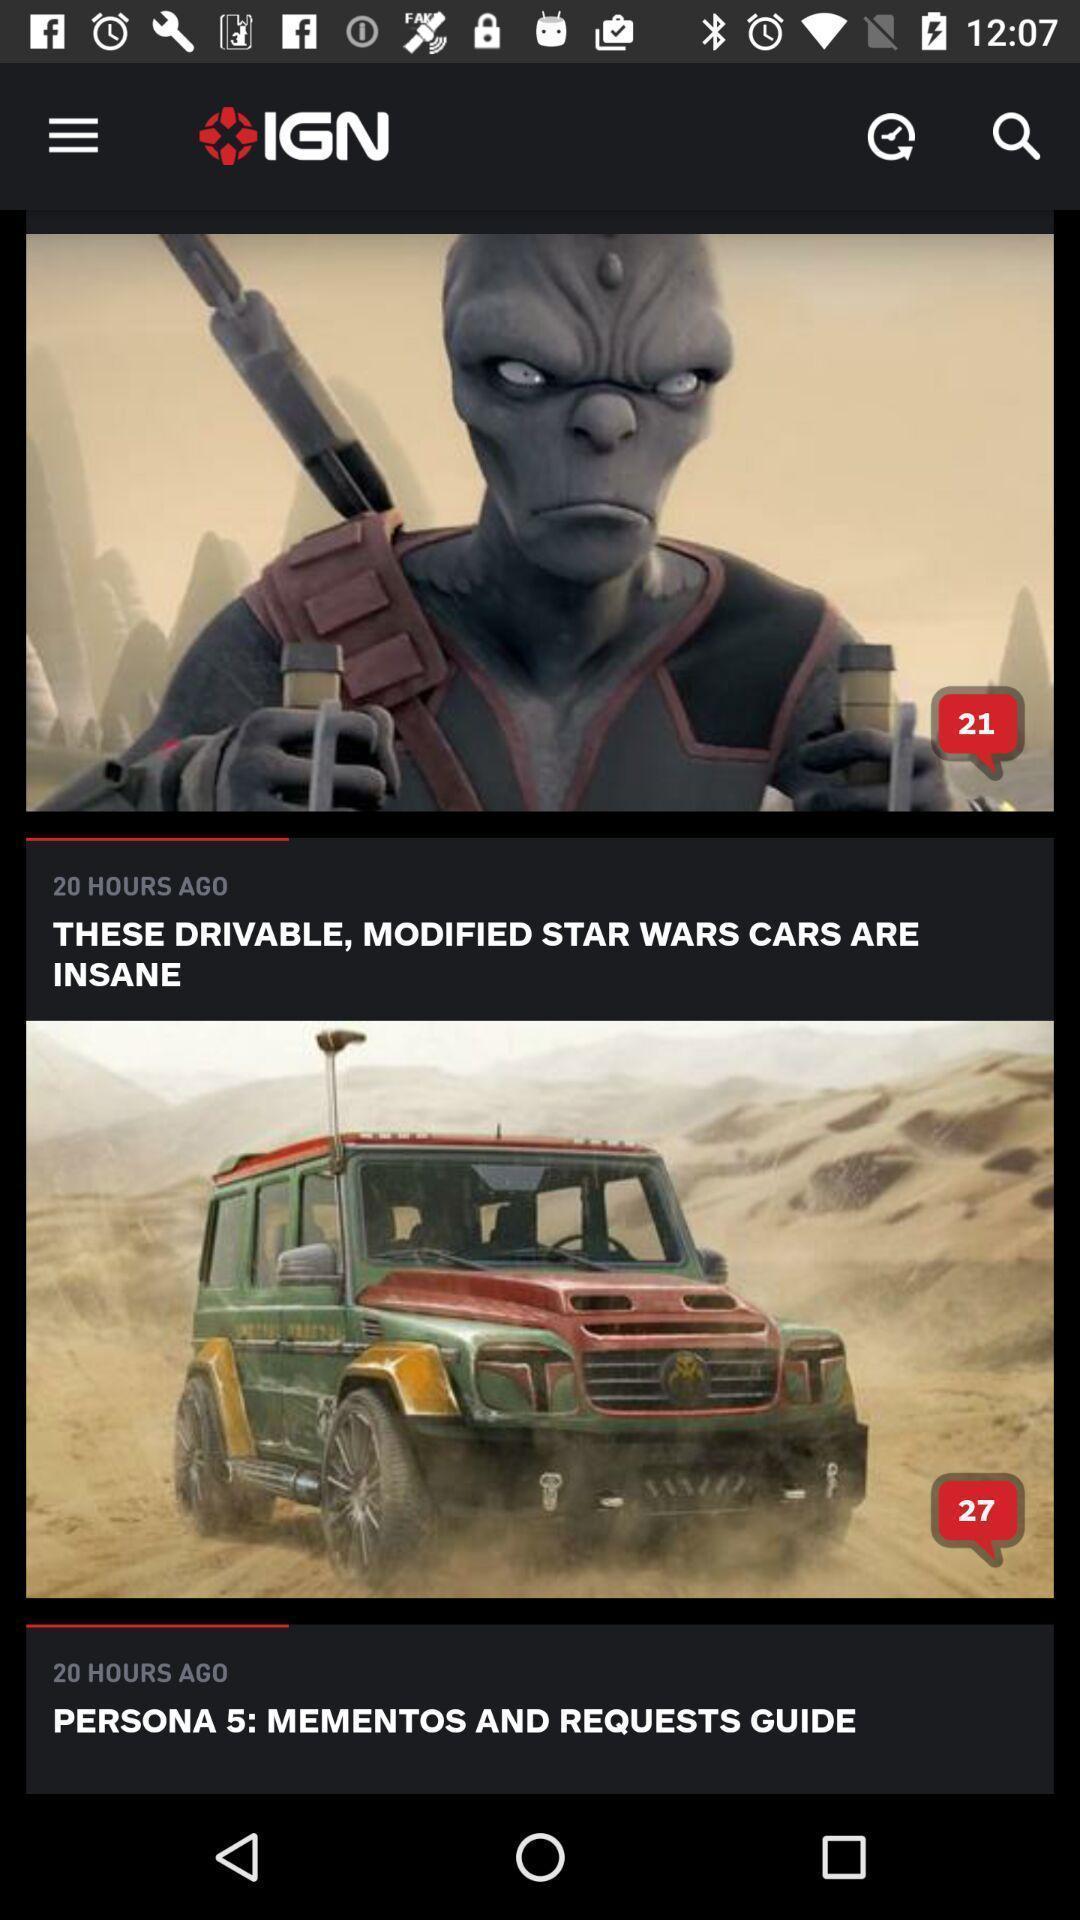Please provide a description for this image. Screen shows articles on a gaming app. 